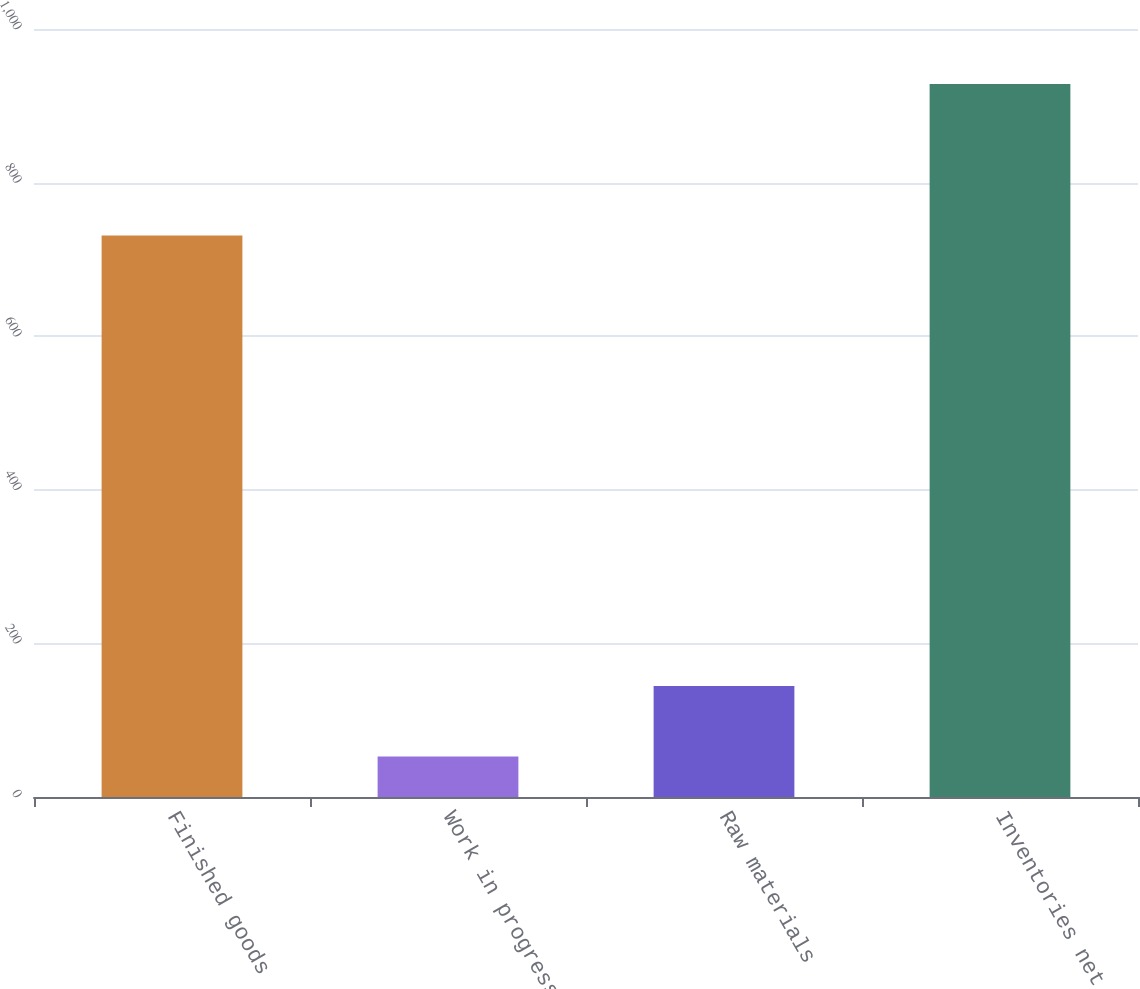<chart> <loc_0><loc_0><loc_500><loc_500><bar_chart><fcel>Finished goods<fcel>Work in progress<fcel>Raw materials<fcel>Inventories net<nl><fcel>731.2<fcel>52.6<fcel>144.5<fcel>928.3<nl></chart> 